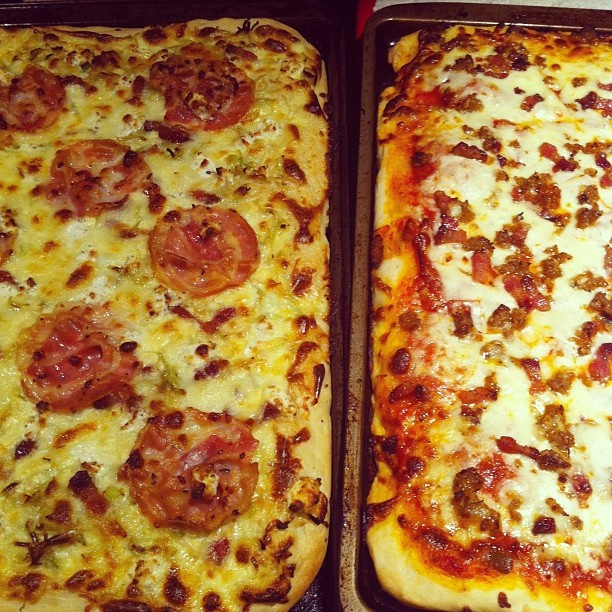Describe the objects in this image and their specific colors. I can see pizza in black, brown, maroon, olive, and tan tones and pizza in black, khaki, brown, and lightyellow tones in this image. 